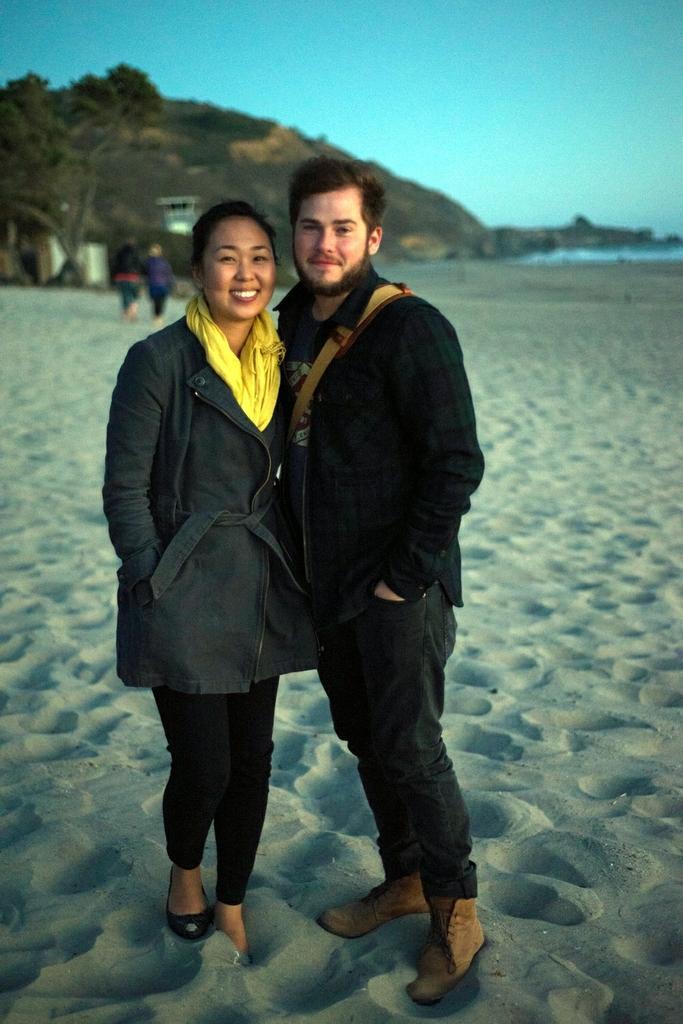Please provide a concise description of this image. In this image I can see two people with black and yellow color dresses and these people are standing on the sand. In the background I can see the trees, few more people, mountains and the sky. To the right I can see the water. 